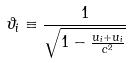Convert formula to latex. <formula><loc_0><loc_0><loc_500><loc_500>\vartheta _ { i } \equiv \frac { 1 } { \sqrt { 1 - \frac { u _ { i } + u _ { i } } { c ^ { 2 } } } }</formula> 